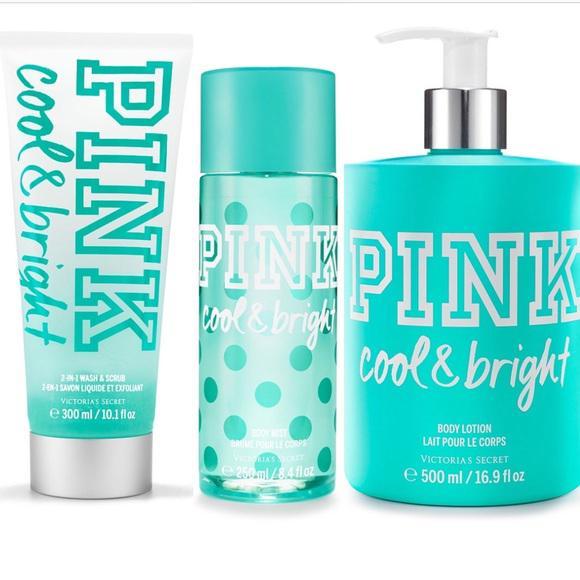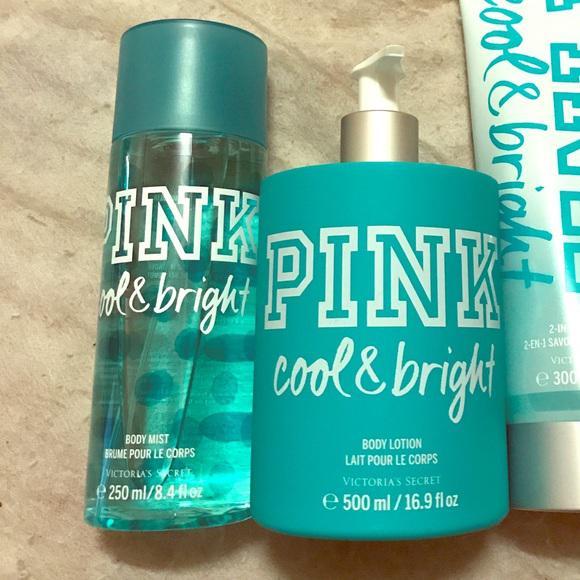The first image is the image on the left, the second image is the image on the right. For the images shown, is this caption "A short wide pump bottle of lotion is shown with one other product in one image and with two other products in the other image." true? Answer yes or no. Yes. The first image is the image on the left, the second image is the image on the right. Given the left and right images, does the statement "The left image shows exactly three products, each in a different packaging format." hold true? Answer yes or no. Yes. 